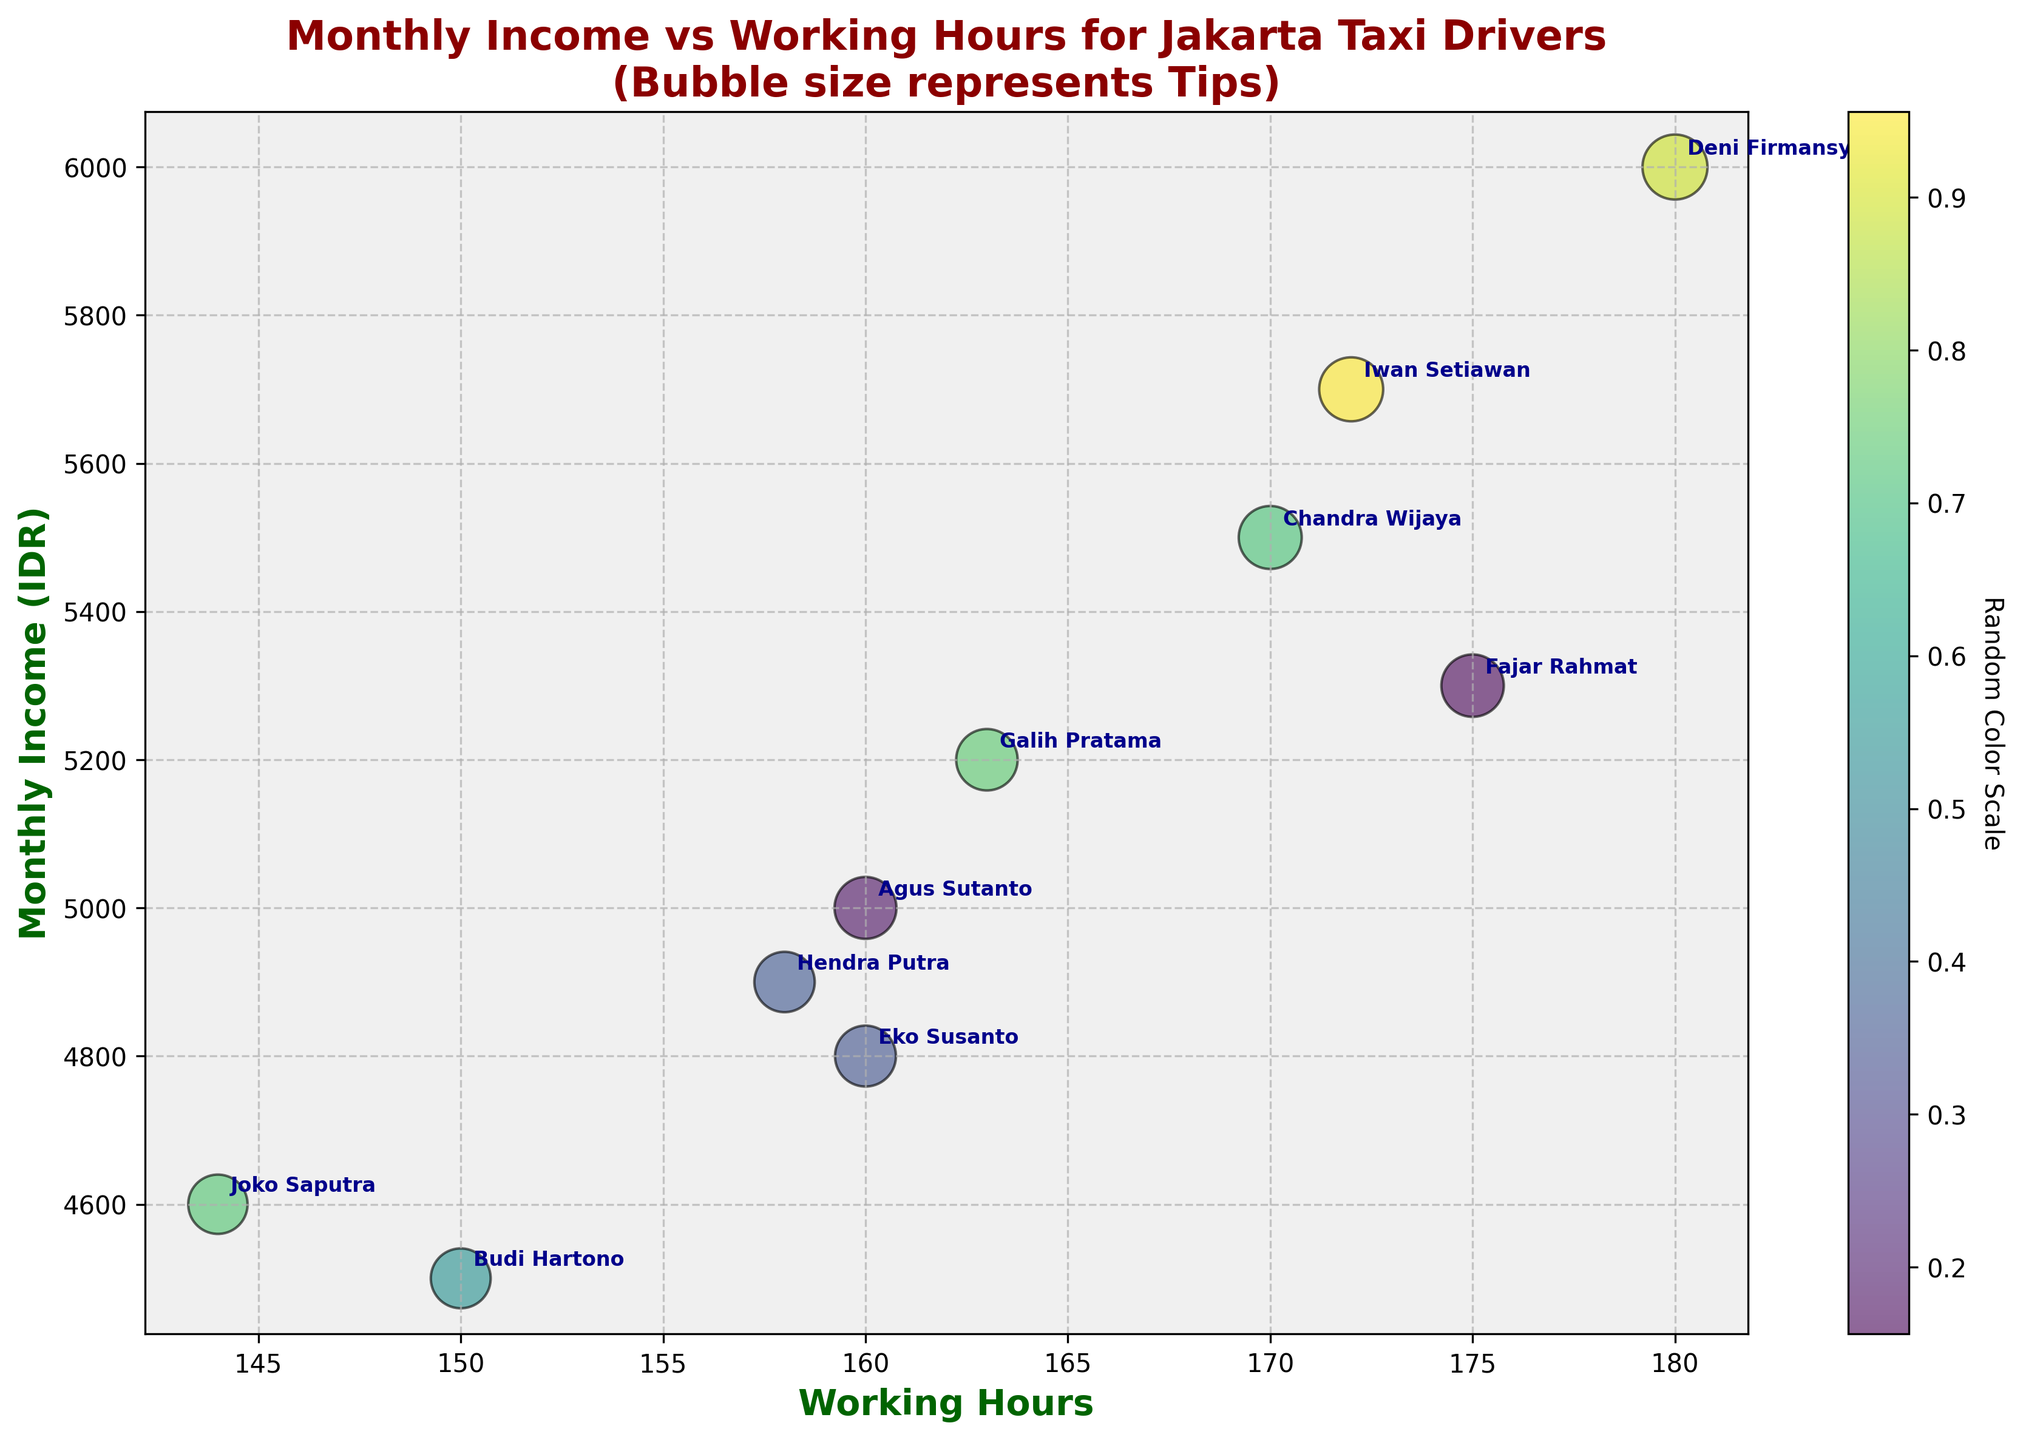What is the title of the chart? Look at the top of the figure to find the title.
Answer: Monthly Income vs Working Hours for Jakarta Taxi Drivers Which driver has the highest monthly income? Identify the driver associated with the highest position on the y-axis.
Answer: Deni Firmansyah How many drivers work 160 hours? Count the data points that correspond to 160 on the x-axis.
Answer: 2 Which driver received the highest tips? Locate the largest bubble size and identify the associated driver.
Answer: Deni Firmansyah Which driver has the lowest working hours? Find the point on the far left of the x-axis and identify the associated driver.
Answer: Joko Saputra What is the range of monthly incomes in the chart? Subtract the minimum monthly income from the maximum monthly income. The maximum is 6000 and the minimum is 4500.
Answer: 1500 Who worked more hours, Agus Sutanto or Joko Saputra? Compare the x-axis positions for Agus Sutanto (160) and Joko Saputra (144).
Answer: Agus Sutanto What is the average monthly income of drivers who work more than 170 hours? Identify the drivers who work more than 170 hours (Chandra Wijaya, Deni Firmansyah, and Fajar Rahmat), then calculate the average monthly income: (5500 + 6000 + 5300) / 3 = 5600.
Answer: 5600 How does the tip amount affect the bubble size? The bubble size represents tips, so larger tips result in bigger bubbles.
Answer: Larger tips result in bigger bubbles How many drivers are shown in the chart? Count the total number of data points.
Answer: 10 